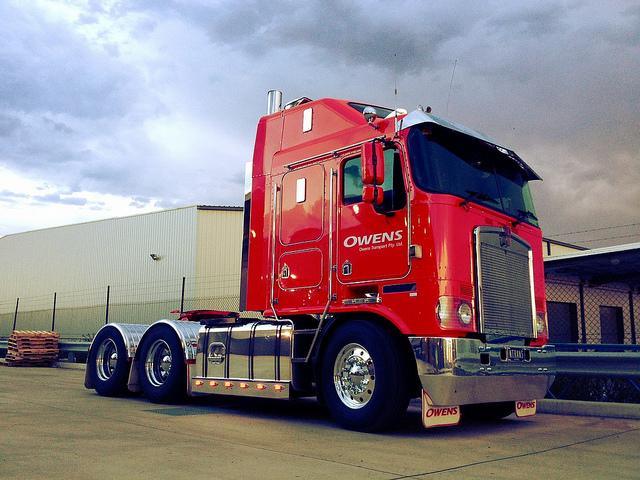What is written on the truck's door?
Answer briefly. Owens. What color is the truck?
Give a very brief answer. Red. What kind of truck is this?
Write a very short answer. Semi. 